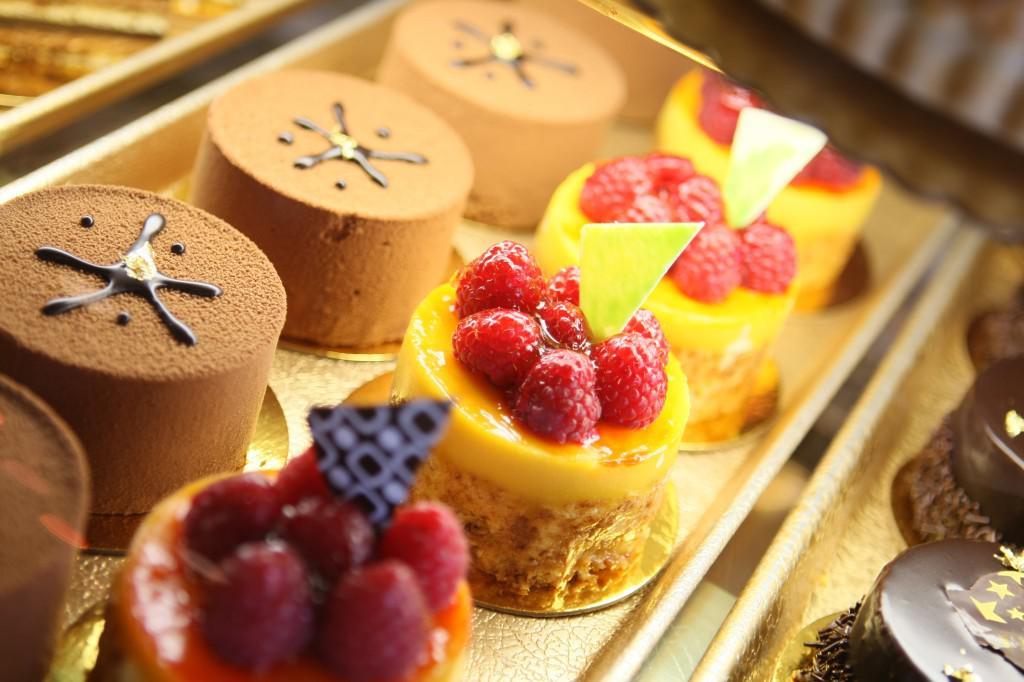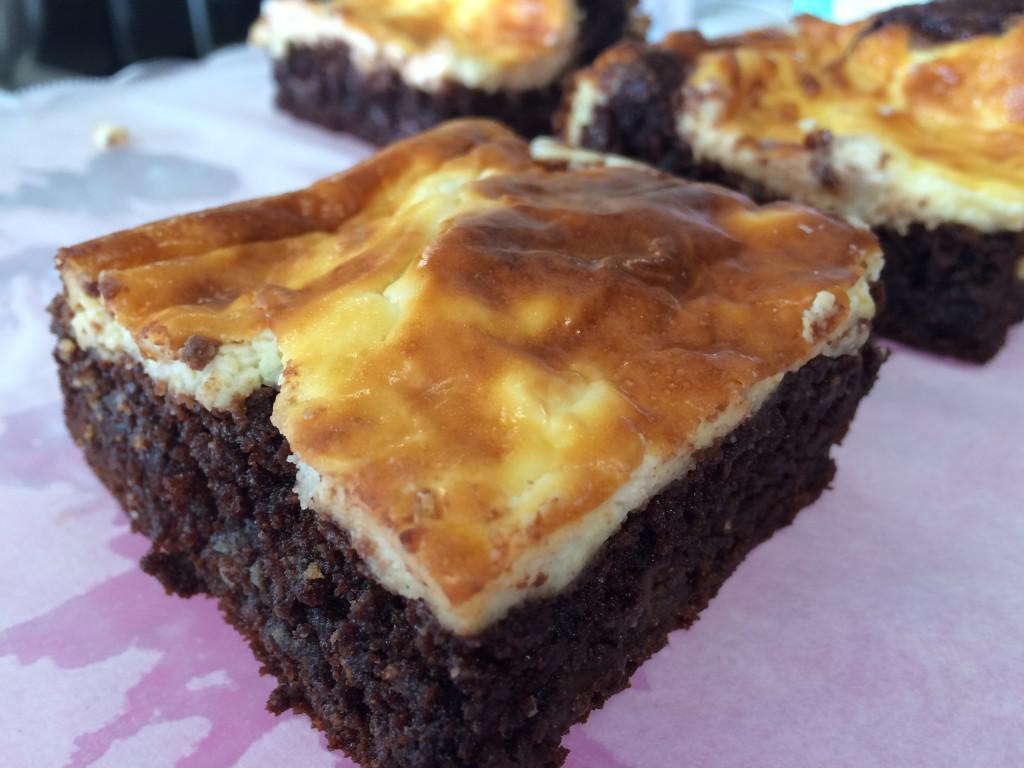The first image is the image on the left, the second image is the image on the right. Given the left and right images, does the statement "There are strawberries on top of some of the desserts." hold true? Answer yes or no. No. The first image is the image on the left, the second image is the image on the right. Assess this claim about the two images: "The left image shows individual round desserts in rows on a tray, and at least one row of desserts have red berries on top.". Correct or not? Answer yes or no. Yes. 